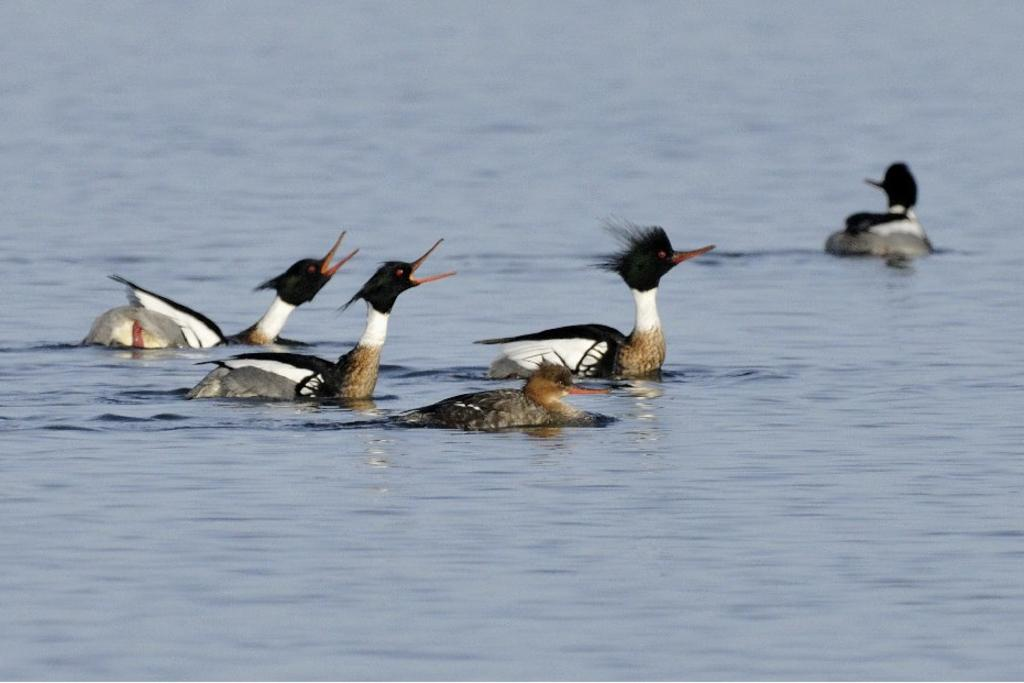What is happening to the animals in the image? The animals are swimming in water. What colors can be seen on the animals in the image? The animals have various colors, including black, white, red, brown, and ash. Can you describe the environment in which the animals are swimming? There is water visible in the background of the image. What type of foot is visible on the animals in the image? The animals in the image are swimming, so their feet are not visible. What form of exercise are the animals doing in the image? The animals are swimming, which is a form of exercise, but we cannot determine the specific type of exercise from the image. 